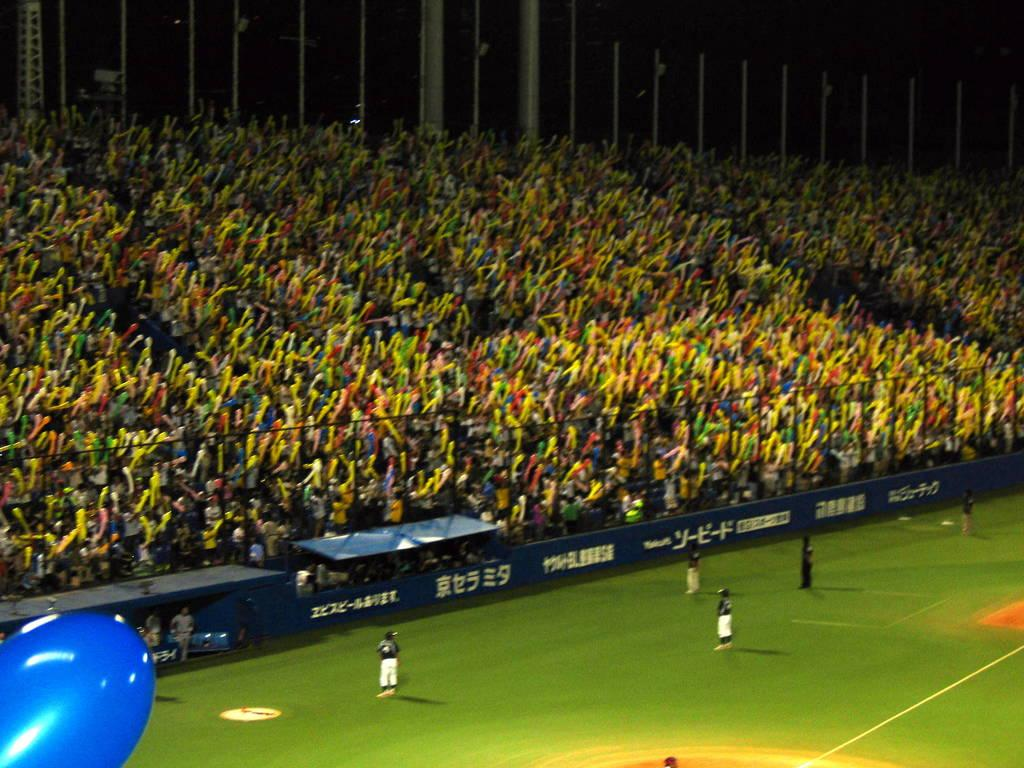Where are the persons located in the image? There are persons standing on the ground and in the stadium. What can be seen in the background of the image? Advertisement boards, sheds, and metal rods are visible in the image. What type of structure is present in the image? Grills are visible in the image. What type of polish is being applied to the minister's shoes in the image? A: There is no minister or polish present in the image. How many potatoes are visible in the image? There are no potatoes visible in the image. 